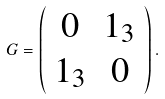Convert formula to latex. <formula><loc_0><loc_0><loc_500><loc_500>G = \left ( \begin{array} { c c } 0 & 1 _ { 3 } \\ 1 _ { 3 } & 0 \end{array} \right ) .</formula> 